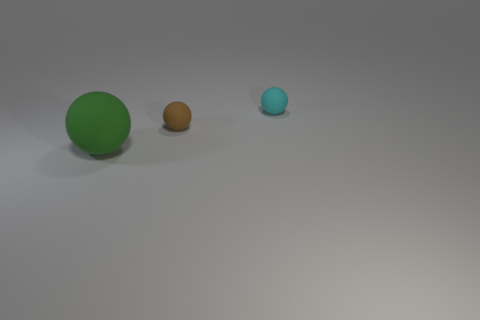The object right of the small brown matte thing is what color?
Ensure brevity in your answer.  Cyan. Do the object right of the tiny brown ball and the object that is left of the brown matte object have the same size?
Your answer should be compact. No. Is there a brown ball that has the same size as the cyan thing?
Provide a short and direct response. Yes. There is a large green sphere to the left of the brown object; what number of cyan things are on the left side of it?
Offer a very short reply. 0. What material is the small brown ball?
Make the answer very short. Rubber. There is a large green ball; how many big green things are behind it?
Keep it short and to the point. 0. How many big rubber things have the same color as the big matte sphere?
Provide a succinct answer. 0. Are there more small things than big green rubber objects?
Offer a terse response. Yes. There is a thing that is both in front of the cyan thing and to the right of the large green rubber sphere; what is its size?
Offer a terse response. Small. Do the small thing in front of the small cyan rubber thing and the ball that is left of the brown rubber thing have the same material?
Keep it short and to the point. Yes. 